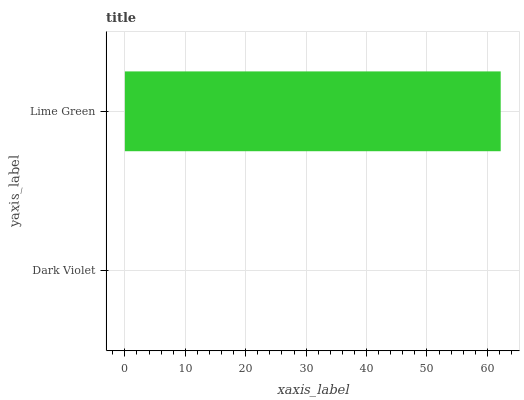Is Dark Violet the minimum?
Answer yes or no. Yes. Is Lime Green the maximum?
Answer yes or no. Yes. Is Lime Green the minimum?
Answer yes or no. No. Is Lime Green greater than Dark Violet?
Answer yes or no. Yes. Is Dark Violet less than Lime Green?
Answer yes or no. Yes. Is Dark Violet greater than Lime Green?
Answer yes or no. No. Is Lime Green less than Dark Violet?
Answer yes or no. No. Is Lime Green the high median?
Answer yes or no. Yes. Is Dark Violet the low median?
Answer yes or no. Yes. Is Dark Violet the high median?
Answer yes or no. No. Is Lime Green the low median?
Answer yes or no. No. 